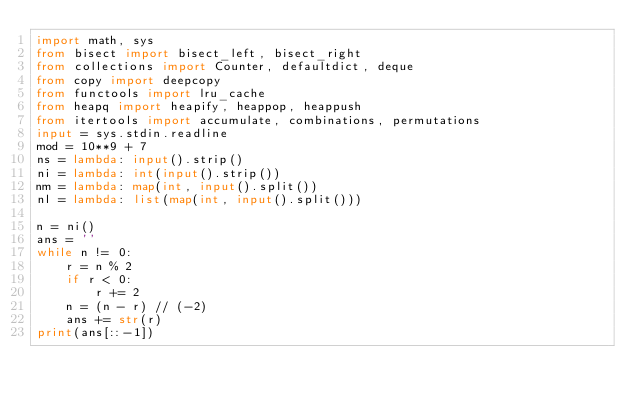<code> <loc_0><loc_0><loc_500><loc_500><_Python_>import math, sys
from bisect import bisect_left, bisect_right
from collections import Counter, defaultdict, deque
from copy import deepcopy
from functools import lru_cache
from heapq import heapify, heappop, heappush
from itertools import accumulate, combinations, permutations
input = sys.stdin.readline
mod = 10**9 + 7
ns = lambda: input().strip()
ni = lambda: int(input().strip())
nm = lambda: map(int, input().split())
nl = lambda: list(map(int, input().split()))

n = ni()
ans = ''
while n != 0:
    r = n % 2
    if r < 0:
        r += 2
    n = (n - r) // (-2)
    ans += str(r)
print(ans[::-1])</code> 